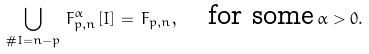Convert formula to latex. <formula><loc_0><loc_0><loc_500><loc_500>\bigcup _ { \# I = n - p } \, F _ { p , n } ^ { \alpha } [ I ] \, = \, F _ { p , n } , \quad \text {for some} \, \alpha > 0 .</formula> 